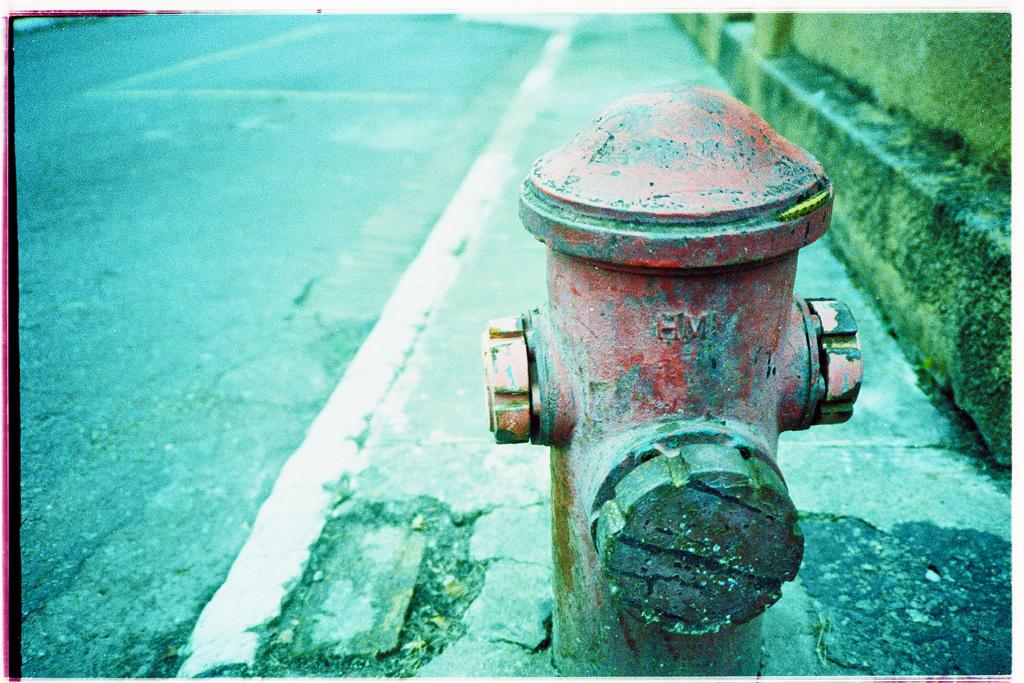What object can be seen in the image that is used for fire safety? There is a fire hydrant in the image. What type of structure is on the right side of the image? There is a wall on the right side of the image. What can be seen on the left side of the image? There is a road on the left side of the image. What type of garden can be seen growing on the fire hydrant in the image? There is no garden growing on the fire hydrant in the image; it is a standalone object for fire safety. 